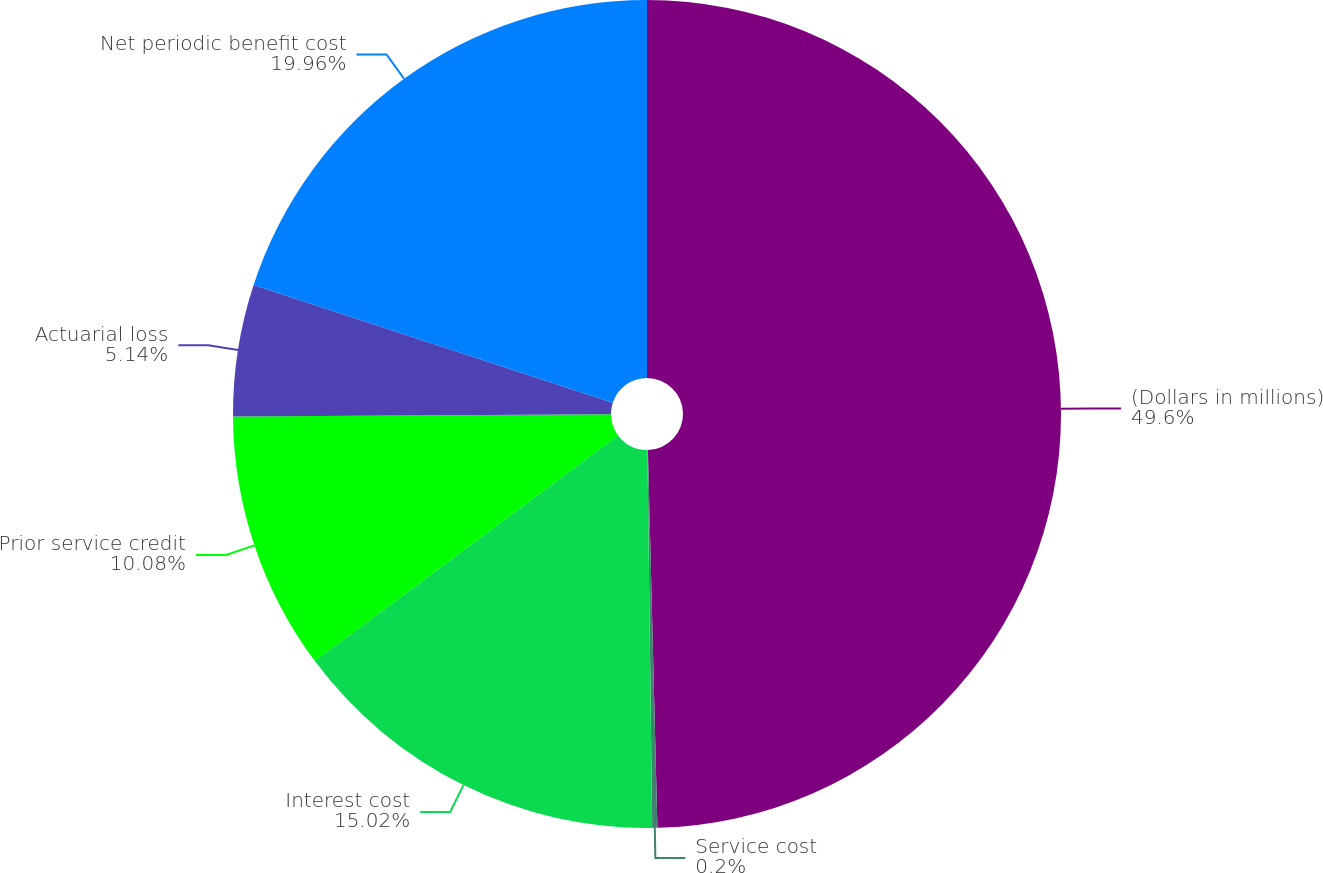Convert chart to OTSL. <chart><loc_0><loc_0><loc_500><loc_500><pie_chart><fcel>(Dollars in millions)<fcel>Service cost<fcel>Interest cost<fcel>Prior service credit<fcel>Actuarial loss<fcel>Net periodic benefit cost<nl><fcel>49.6%<fcel>0.2%<fcel>15.02%<fcel>10.08%<fcel>5.14%<fcel>19.96%<nl></chart> 